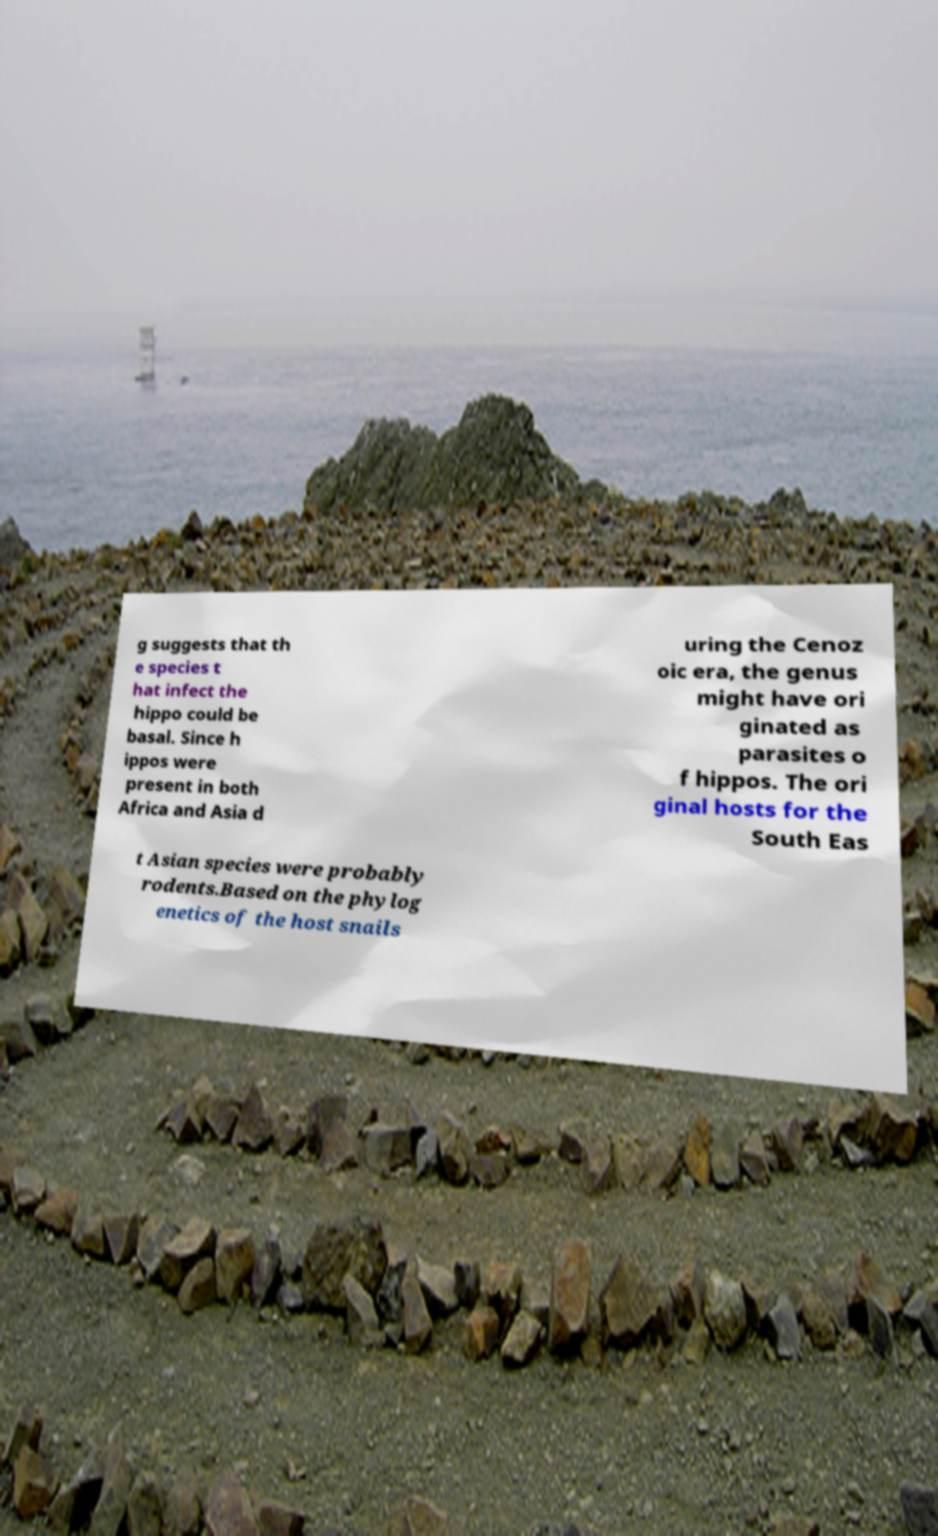There's text embedded in this image that I need extracted. Can you transcribe it verbatim? g suggests that th e species t hat infect the hippo could be basal. Since h ippos were present in both Africa and Asia d uring the Cenoz oic era, the genus might have ori ginated as parasites o f hippos. The ori ginal hosts for the South Eas t Asian species were probably rodents.Based on the phylog enetics of the host snails 